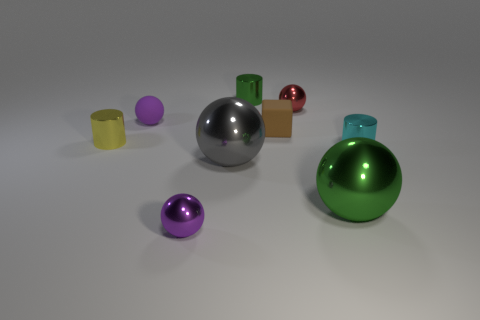There is a purple thing that is behind the purple metallic sphere; is its size the same as the small cyan thing?
Make the answer very short. Yes. There is a gray sphere behind the tiny purple sphere that is in front of the small yellow metallic thing; how big is it?
Provide a short and direct response. Large. Are the gray sphere and the purple object that is in front of the small cyan thing made of the same material?
Give a very brief answer. Yes. Is the number of small balls that are right of the small red sphere less than the number of tiny rubber things that are to the right of the small green thing?
Make the answer very short. Yes. What is the color of the big object that is made of the same material as the green ball?
Provide a succinct answer. Gray. Are there any red objects right of the tiny cylinder that is in front of the yellow cylinder?
Give a very brief answer. No. What is the color of the rubber cube that is the same size as the purple matte object?
Make the answer very short. Brown. How many things are either tiny rubber spheres or rubber objects?
Keep it short and to the point. 2. What is the size of the purple sphere in front of the small purple object that is to the left of the tiny ball that is in front of the purple matte thing?
Keep it short and to the point. Small. How many other spheres have the same color as the tiny matte ball?
Provide a short and direct response. 1. 